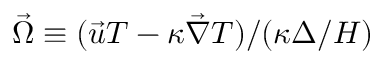Convert formula to latex. <formula><loc_0><loc_0><loc_500><loc_500>{ \vec { \Omega } \equiv ( \vec { u } T - \kappa \vec { \nabla } T ) / } ( \kappa \Delta / H )</formula> 